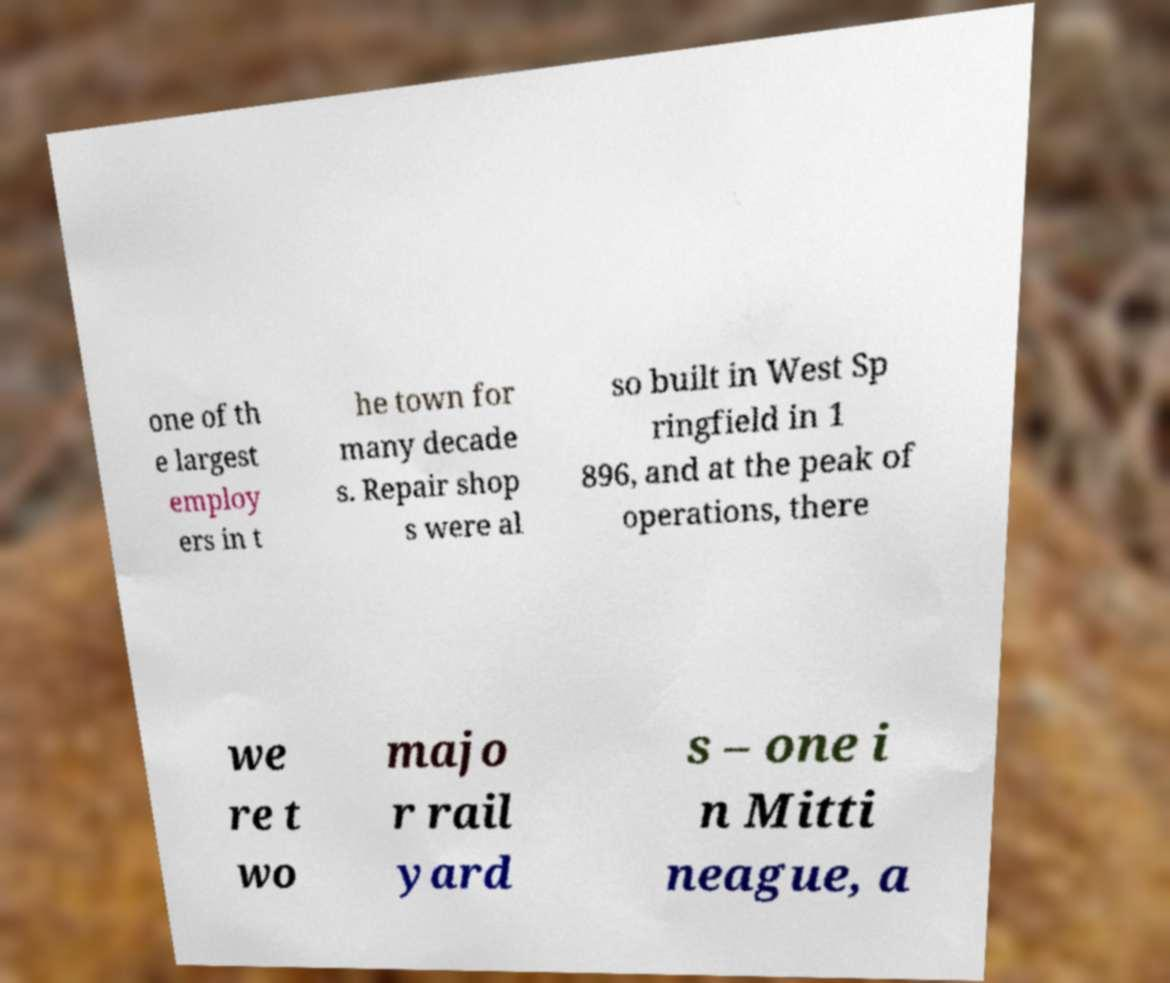For documentation purposes, I need the text within this image transcribed. Could you provide that? one of th e largest employ ers in t he town for many decade s. Repair shop s were al so built in West Sp ringfield in 1 896, and at the peak of operations, there we re t wo majo r rail yard s – one i n Mitti neague, a 